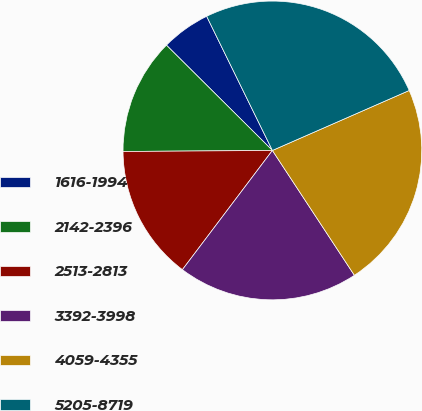Convert chart to OTSL. <chart><loc_0><loc_0><loc_500><loc_500><pie_chart><fcel>1616-1994<fcel>2142-2396<fcel>2513-2813<fcel>3392-3998<fcel>4059-4355<fcel>5205-8719<nl><fcel>5.3%<fcel>12.56%<fcel>14.6%<fcel>19.54%<fcel>22.33%<fcel>25.68%<nl></chart> 